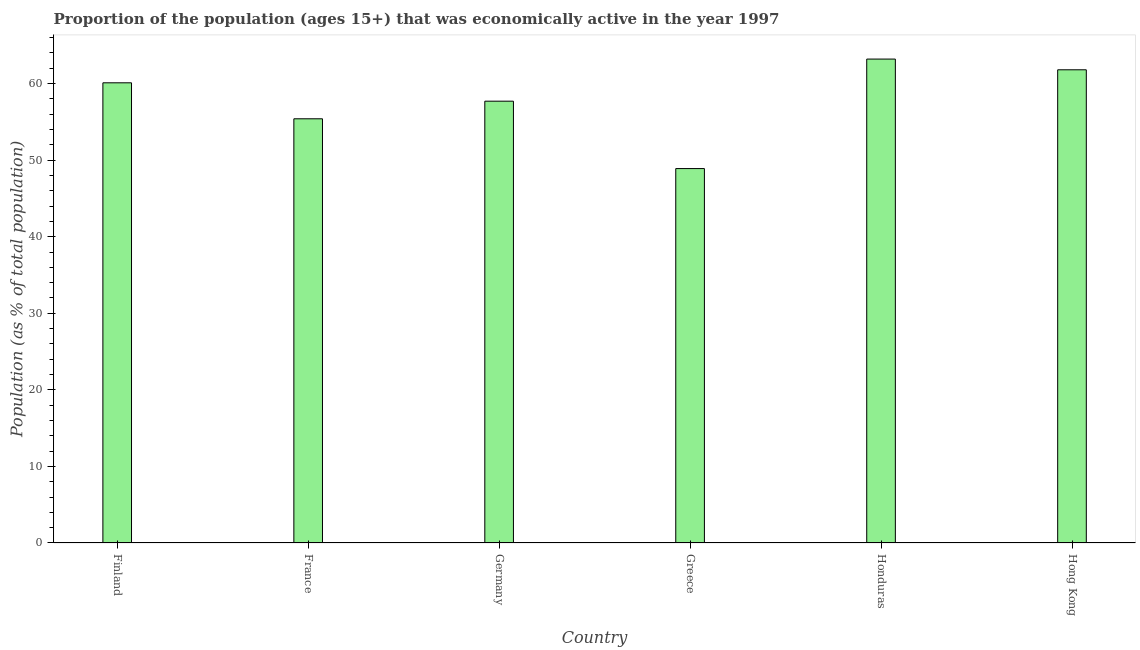Does the graph contain grids?
Provide a succinct answer. No. What is the title of the graph?
Offer a terse response. Proportion of the population (ages 15+) that was economically active in the year 1997. What is the label or title of the Y-axis?
Ensure brevity in your answer.  Population (as % of total population). What is the percentage of economically active population in Honduras?
Give a very brief answer. 63.2. Across all countries, what is the maximum percentage of economically active population?
Provide a short and direct response. 63.2. Across all countries, what is the minimum percentage of economically active population?
Give a very brief answer. 48.9. In which country was the percentage of economically active population maximum?
Give a very brief answer. Honduras. What is the sum of the percentage of economically active population?
Your answer should be compact. 347.1. What is the difference between the percentage of economically active population in Greece and Honduras?
Provide a short and direct response. -14.3. What is the average percentage of economically active population per country?
Offer a terse response. 57.85. What is the median percentage of economically active population?
Ensure brevity in your answer.  58.9. Is the percentage of economically active population in France less than that in Germany?
Ensure brevity in your answer.  Yes. Is the difference between the percentage of economically active population in Finland and Germany greater than the difference between any two countries?
Your response must be concise. No. What is the difference between the highest and the second highest percentage of economically active population?
Your response must be concise. 1.4. Is the sum of the percentage of economically active population in France and Greece greater than the maximum percentage of economically active population across all countries?
Keep it short and to the point. Yes. In how many countries, is the percentage of economically active population greater than the average percentage of economically active population taken over all countries?
Your response must be concise. 3. How many bars are there?
Give a very brief answer. 6. Are all the bars in the graph horizontal?
Offer a terse response. No. How many countries are there in the graph?
Offer a very short reply. 6. What is the difference between two consecutive major ticks on the Y-axis?
Provide a short and direct response. 10. Are the values on the major ticks of Y-axis written in scientific E-notation?
Your answer should be compact. No. What is the Population (as % of total population) in Finland?
Your response must be concise. 60.1. What is the Population (as % of total population) of France?
Ensure brevity in your answer.  55.4. What is the Population (as % of total population) of Germany?
Make the answer very short. 57.7. What is the Population (as % of total population) of Greece?
Make the answer very short. 48.9. What is the Population (as % of total population) in Honduras?
Your answer should be compact. 63.2. What is the Population (as % of total population) of Hong Kong?
Make the answer very short. 61.8. What is the difference between the Population (as % of total population) in Finland and Greece?
Ensure brevity in your answer.  11.2. What is the difference between the Population (as % of total population) in France and Germany?
Provide a short and direct response. -2.3. What is the difference between the Population (as % of total population) in France and Greece?
Your response must be concise. 6.5. What is the difference between the Population (as % of total population) in France and Honduras?
Give a very brief answer. -7.8. What is the difference between the Population (as % of total population) in Germany and Honduras?
Keep it short and to the point. -5.5. What is the difference between the Population (as % of total population) in Greece and Honduras?
Your response must be concise. -14.3. What is the difference between the Population (as % of total population) in Honduras and Hong Kong?
Provide a short and direct response. 1.4. What is the ratio of the Population (as % of total population) in Finland to that in France?
Provide a short and direct response. 1.08. What is the ratio of the Population (as % of total population) in Finland to that in Germany?
Provide a short and direct response. 1.04. What is the ratio of the Population (as % of total population) in Finland to that in Greece?
Offer a very short reply. 1.23. What is the ratio of the Population (as % of total population) in Finland to that in Honduras?
Offer a terse response. 0.95. What is the ratio of the Population (as % of total population) in France to that in Germany?
Provide a short and direct response. 0.96. What is the ratio of the Population (as % of total population) in France to that in Greece?
Your answer should be very brief. 1.13. What is the ratio of the Population (as % of total population) in France to that in Honduras?
Offer a very short reply. 0.88. What is the ratio of the Population (as % of total population) in France to that in Hong Kong?
Your response must be concise. 0.9. What is the ratio of the Population (as % of total population) in Germany to that in Greece?
Make the answer very short. 1.18. What is the ratio of the Population (as % of total population) in Germany to that in Hong Kong?
Make the answer very short. 0.93. What is the ratio of the Population (as % of total population) in Greece to that in Honduras?
Offer a terse response. 0.77. What is the ratio of the Population (as % of total population) in Greece to that in Hong Kong?
Your answer should be very brief. 0.79. 